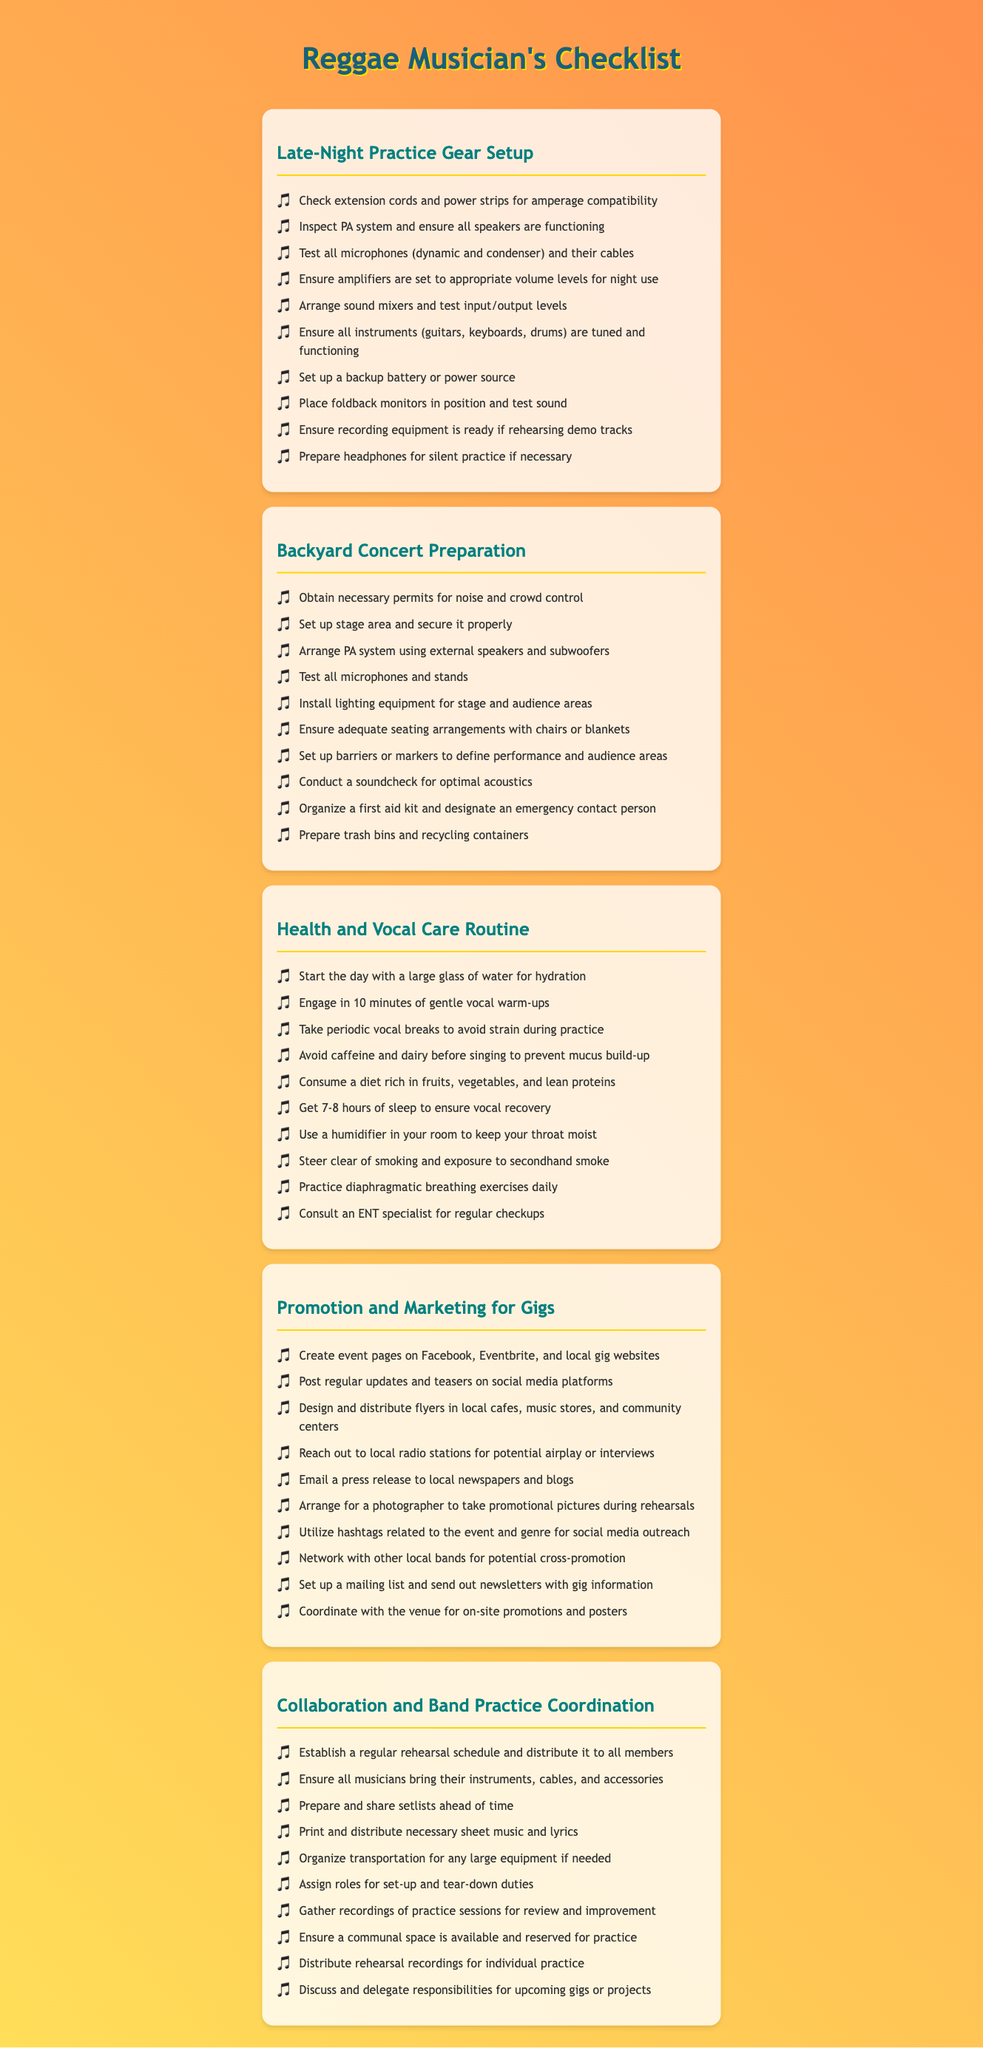what is the first item on the Late-Night Practice Gear Setup? The first item listed helps ensure the appropriate electrical supply for equipment used in practice.
Answer: Check extension cords and power strips for amperage compatibility how many items are listed in the Backyard Concert Preparation? The number of items in this checklist indicates the preparations required for an outdoor concert.
Answer: 10 what is one health recommendation for vocal care? This recommendation aims to enhance vocal performance and overall health.
Answer: Start the day with a large glass of water for hydration what should be prepared for coordinating band practices? This essential item ensures that all members come prepared and organized for practice.
Answer: Setlists which strategy is suggested for promoting gigs effectively? This strategy helps to spread the word about the event and reach a larger audience.
Answer: Create event pages on Facebook, Eventbrite, and local gig websites name an item that should be included in the Health and Vocal Care Routine. Including this item helps maintain vocal strength and prevents strain.
Answer: Gentle vocal warm-ups how many checklists are in the document? The total number of checklists reflects the areas of focus for a reggae musician.
Answer: 5 what is a suggested action to ensure safety during a backyard concert? This action helps to mitigate risks associated with outdoor crowd gatherings.
Answer: Organize a first aid kit and designate an emergency contact person what is one of the responsibilities to be discussed during band practice coordination? This aspect emphasizes collaborative planning for a successful performance.
Answer: Responsibilities for upcoming gigs or projects 